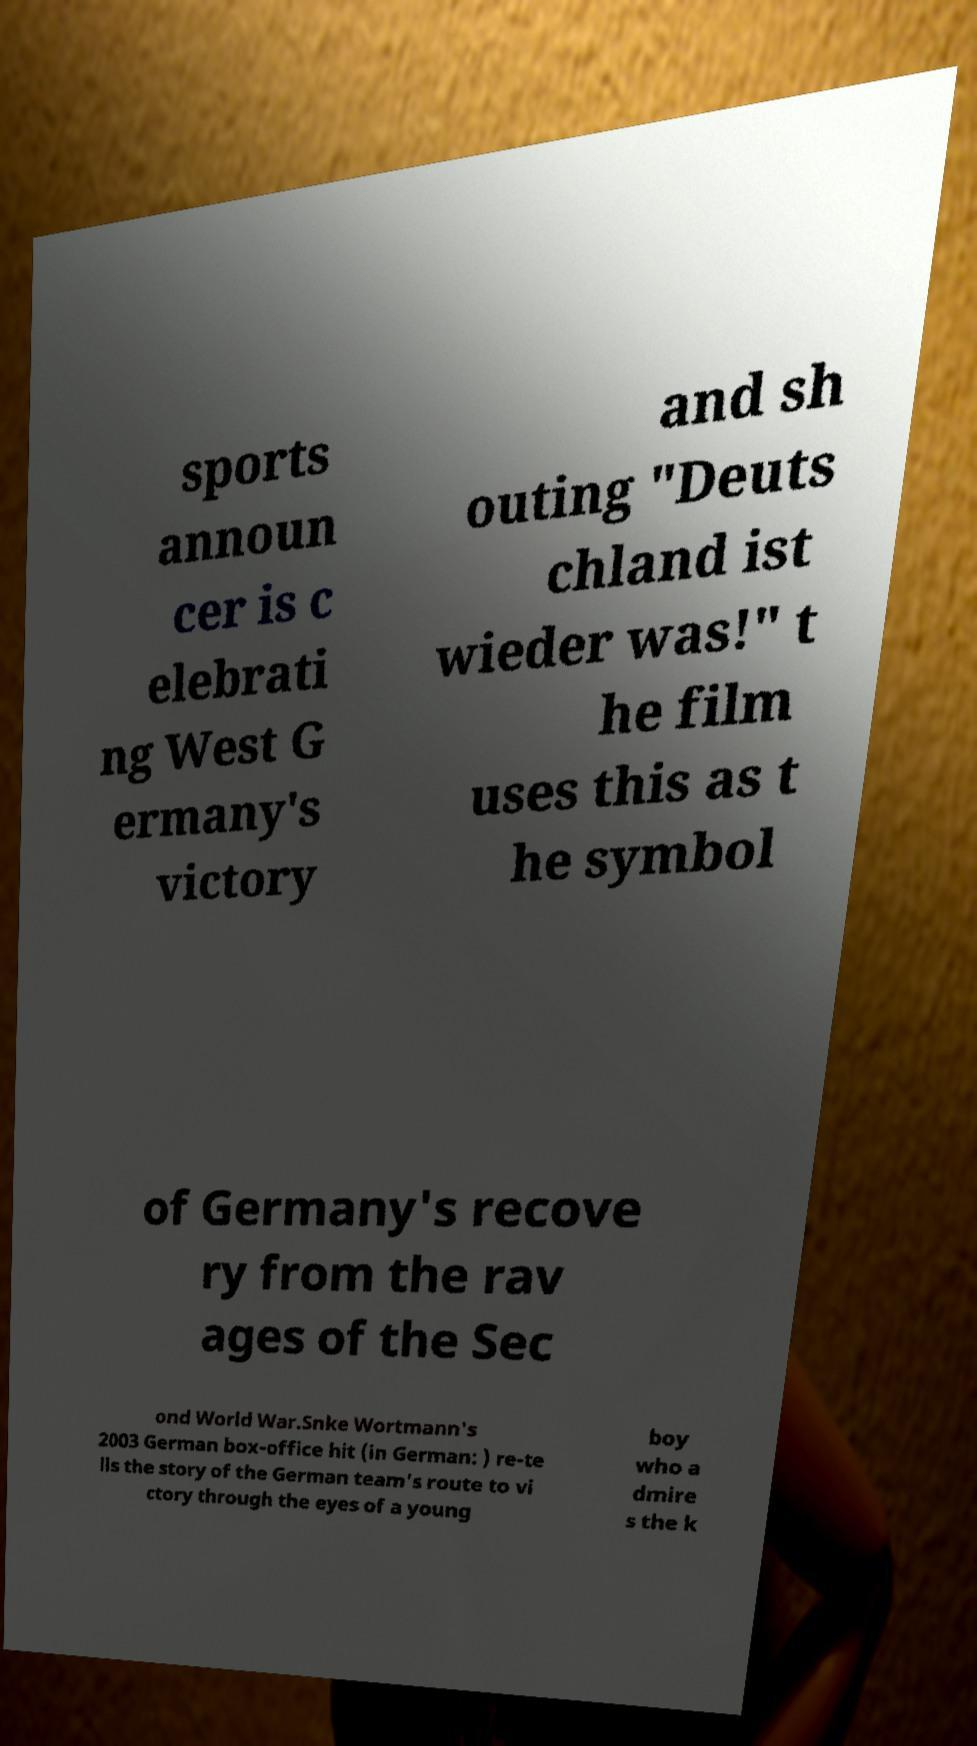I need the written content from this picture converted into text. Can you do that? sports announ cer is c elebrati ng West G ermany's victory and sh outing "Deuts chland ist wieder was!" t he film uses this as t he symbol of Germany's recove ry from the rav ages of the Sec ond World War.Snke Wortmann's 2003 German box-office hit (in German: ) re-te lls the story of the German team's route to vi ctory through the eyes of a young boy who a dmire s the k 